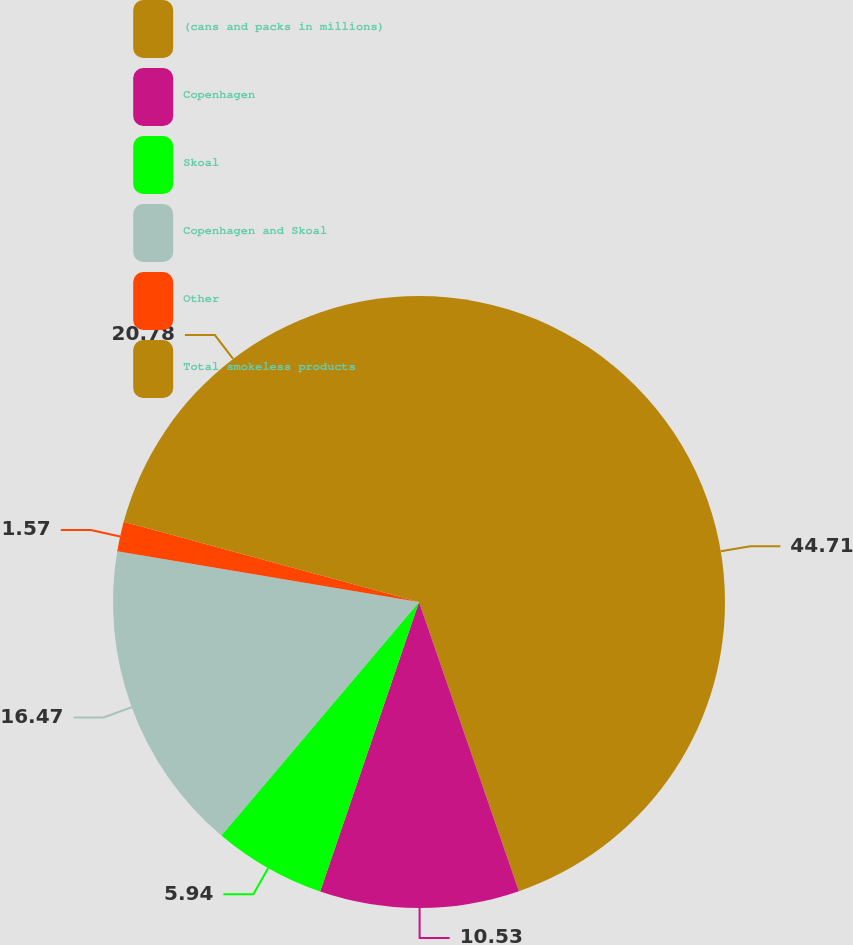Convert chart. <chart><loc_0><loc_0><loc_500><loc_500><pie_chart><fcel>(cans and packs in millions)<fcel>Copenhagen<fcel>Skoal<fcel>Copenhagen and Skoal<fcel>Other<fcel>Total smokeless products<nl><fcel>44.7%<fcel>10.53%<fcel>5.94%<fcel>16.47%<fcel>1.57%<fcel>20.78%<nl></chart> 